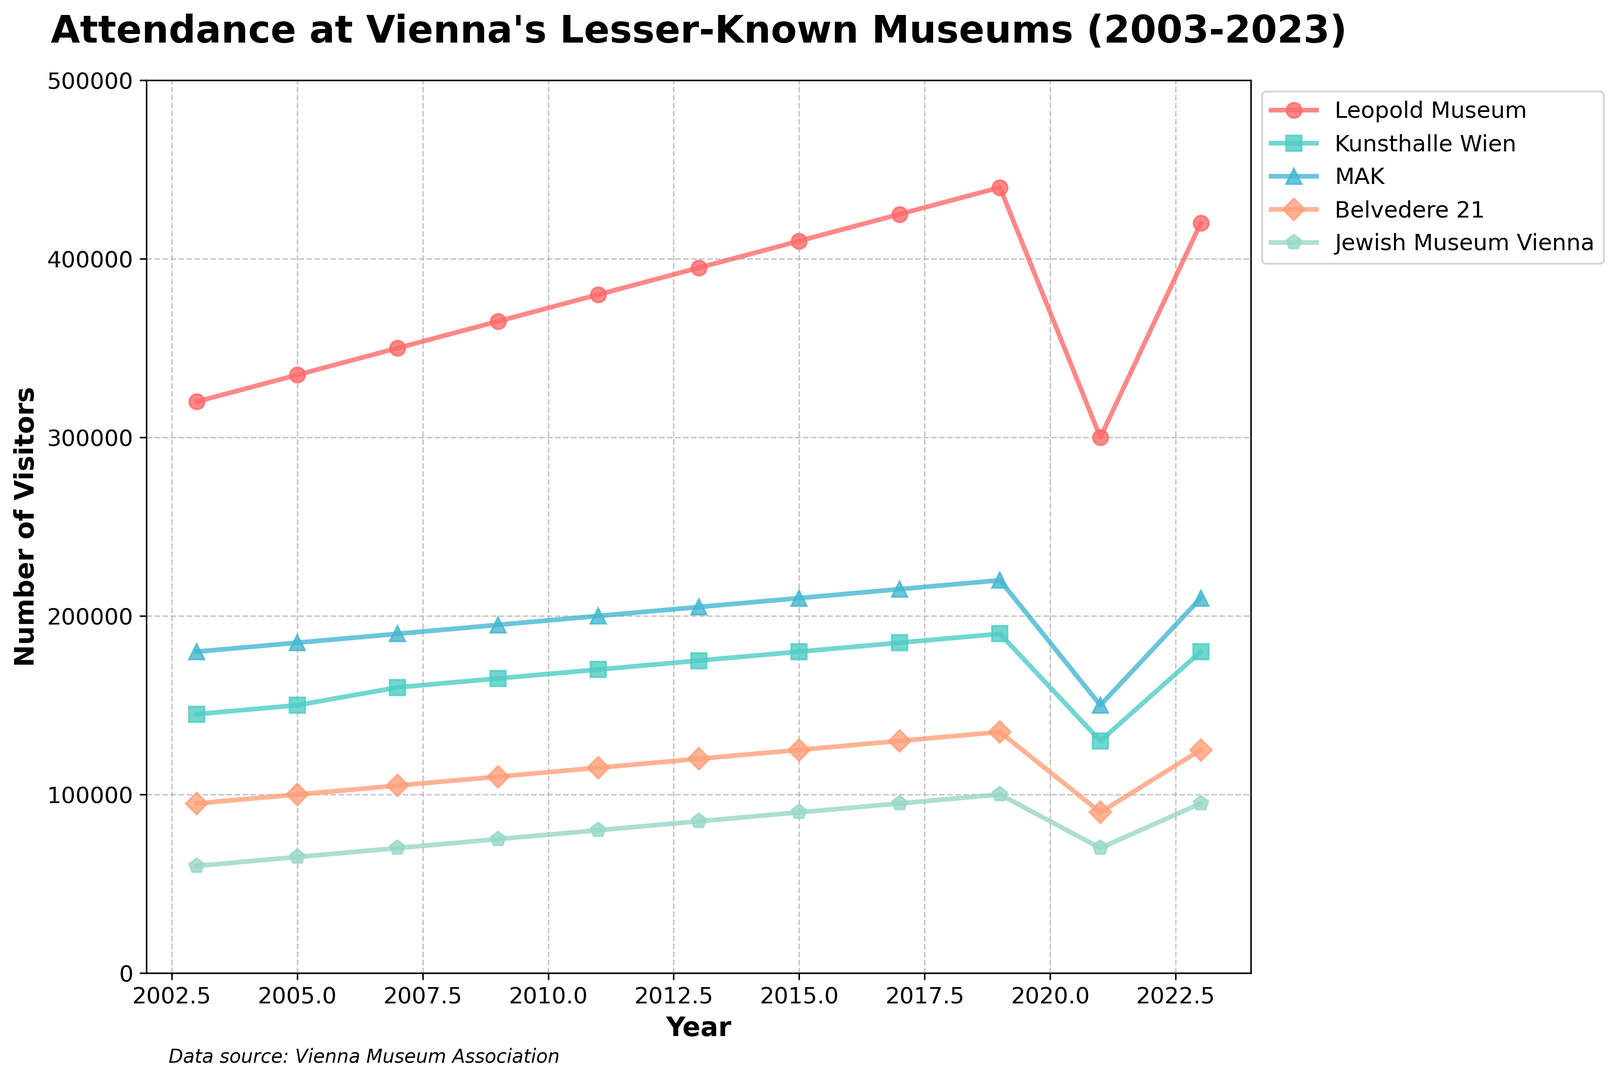What was the attendance at the Leopold Museum in 2013? Look for the line corresponding to the Leopold Museum and find the value for the year 2013.
Answer: 395,000 How did the attendance at Kunsthalle Wien change from 2003 to 2023? Subtract the 2003 attendance figure from the 2023 attendance figure for Kunsthalle Wien. 2023: 180,000, 2003: 145,000. So, 180,000 - 145,000.
Answer: 35,000 Which museum saw the biggest drop in attendance in 2021? Compare the attendance figures for all museums in 2021 and note the values for the previous year (2019). Identify the museum with the largest decrease.
Answer: Leopold Museum What was the average attendance at the Belvedere 21 museum over the 20-year period? Add up all the attendance figures for Belvedere 21 and divide by the number of data points (11). (95,000 + 100,000 + 105,000 + 110,000 + 115,000 + 120,000 + 125,000 + 130,000 + 135,000 + 90,000 + 125,000) / 11.
Answer: 113,182 Compare the overall trend between the Jewish Museum Vienna and MAK. Which one had a more consistent increase over the years? Analyze the data points for each year for both the Jewish Museum Vienna and MAK. The Jewish Museum Vienna has smaller, more consistent increments compared to MAK's larger fluctuations.
Answer: Jewish Museum Vienna How many years did the Leopold Museum have attendance figures above 400,000? Count the number of years where the line for the Leopold Museum is above 400,000 on the y-axis.
Answer: 3 What was the percentage drop in attendance for Jewish Museum Vienna from 2019 to 2021? Calculate the drop in attendance (100,000 to 70,000). Divide the drop by the 2019 figure and multiply by 100. (100,000 - 70,000) / 100,000 * 100.
Answer: 30% Which museum had the lowest attendance in 2007? Compare the attendance figures for all museums in 2007 and identify the lowest value.
Answer: Jewish Museum Vienna By how much did the attendance at the MAK increase from 2003 to 2017? Subtract the 2003 attendance figure from the 2017 figure for MAK. 2017: 215,000, 2003: 180,000. So, 215,000 - 180,000.
Answer: 35,000 